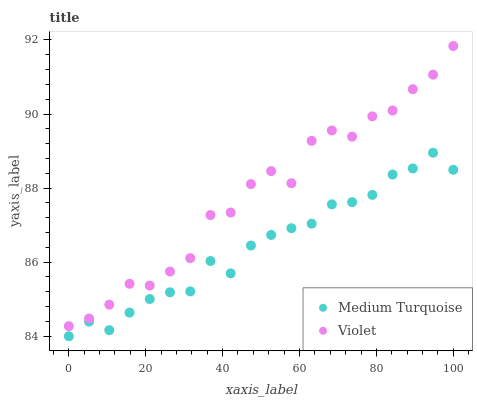Does Medium Turquoise have the minimum area under the curve?
Answer yes or no. Yes. Does Violet have the maximum area under the curve?
Answer yes or no. Yes. Does Violet have the minimum area under the curve?
Answer yes or no. No. Is Medium Turquoise the smoothest?
Answer yes or no. Yes. Is Violet the roughest?
Answer yes or no. Yes. Is Violet the smoothest?
Answer yes or no. No. Does Medium Turquoise have the lowest value?
Answer yes or no. Yes. Does Violet have the lowest value?
Answer yes or no. No. Does Violet have the highest value?
Answer yes or no. Yes. Is Medium Turquoise less than Violet?
Answer yes or no. Yes. Is Violet greater than Medium Turquoise?
Answer yes or no. Yes. Does Medium Turquoise intersect Violet?
Answer yes or no. No. 